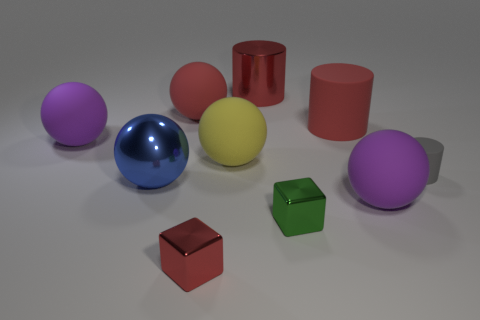Subtract 1 spheres. How many spheres are left? 4 Subtract all big red rubber balls. How many balls are left? 4 Subtract all blue spheres. How many spheres are left? 4 Subtract all blue spheres. Subtract all blue cylinders. How many spheres are left? 4 Subtract all cylinders. How many objects are left? 7 Subtract 0 brown cylinders. How many objects are left? 10 Subtract all green blocks. Subtract all large yellow rubber spheres. How many objects are left? 8 Add 3 red metallic cubes. How many red metallic cubes are left? 4 Add 4 big blue shiny objects. How many big blue shiny objects exist? 5 